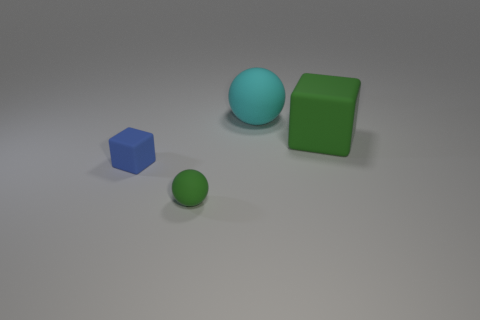How many other things are the same shape as the tiny blue rubber object?
Provide a succinct answer. 1. Is the big cube the same color as the small ball?
Make the answer very short. Yes. What number of things are either large green blocks or small objects behind the small ball?
Give a very brief answer. 2. Is there a blue matte block of the same size as the green matte cube?
Provide a short and direct response. No. What number of objects are either small rubber spheres or tiny purple shiny cylinders?
Ensure brevity in your answer.  1. How big is the blue matte block?
Your answer should be compact. Small. Is the number of large cyan spheres less than the number of matte objects?
Offer a terse response. Yes. What number of other big matte cubes are the same color as the big block?
Keep it short and to the point. 0. Is the color of the big rubber block to the right of the small blue rubber cube the same as the tiny matte sphere?
Make the answer very short. Yes. What is the shape of the green object that is on the right side of the big cyan matte thing?
Offer a very short reply. Cube. 